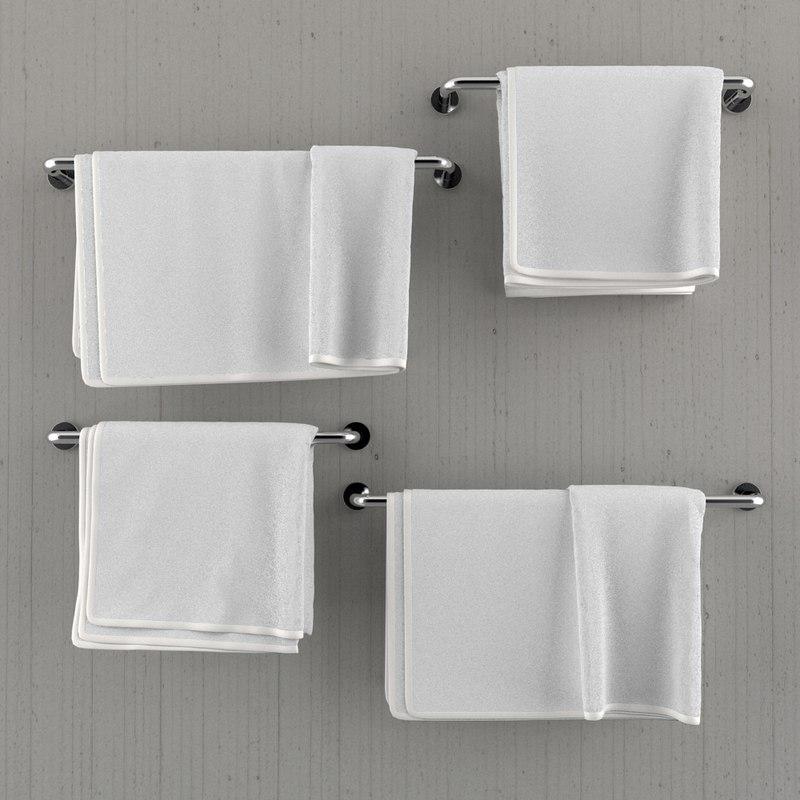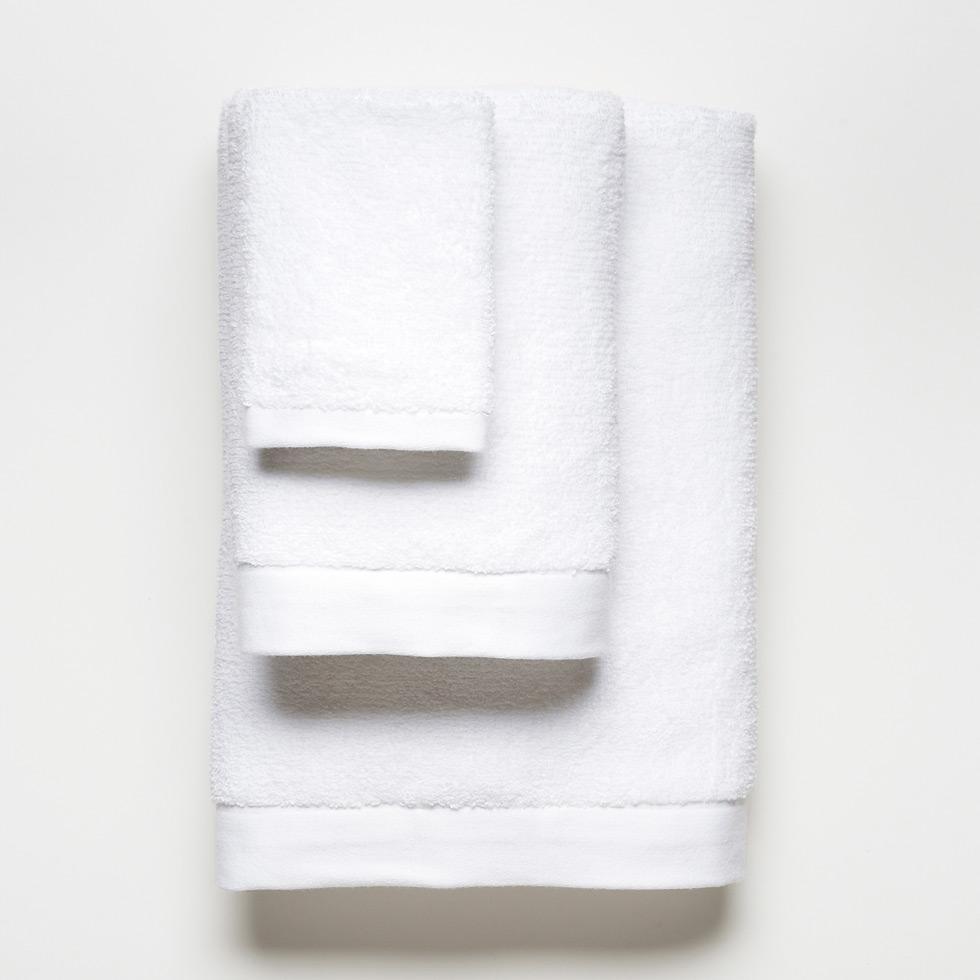The first image is the image on the left, the second image is the image on the right. Assess this claim about the two images: "In one of the images there is a single white towel hanging on a towel bar.". Correct or not? Answer yes or no. No. 